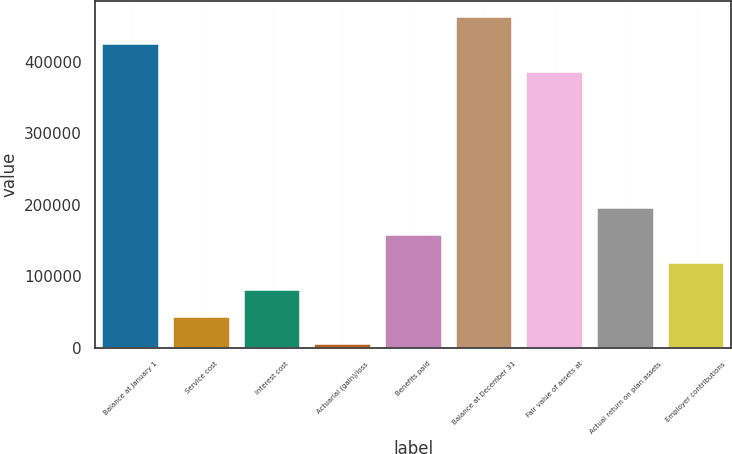Convert chart. <chart><loc_0><loc_0><loc_500><loc_500><bar_chart><fcel>Balance at January 1<fcel>Service cost<fcel>Interest cost<fcel>Actuarial (gain)/loss<fcel>Benefits paid<fcel>Balance at December 31<fcel>Fair value of assets at<fcel>Actual return on plan assets<fcel>Employer contributions<nl><fcel>424575<fcel>42483.2<fcel>80692.4<fcel>4274<fcel>157111<fcel>462784<fcel>386366<fcel>195320<fcel>118902<nl></chart> 